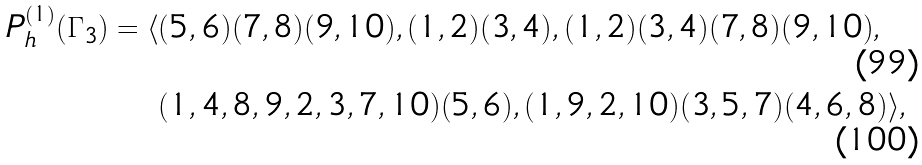<formula> <loc_0><loc_0><loc_500><loc_500>P _ { h } ^ { ( 1 ) } ( \Gamma _ { 3 } ) = \langle & ( 5 , 6 ) ( 7 , 8 ) ( 9 , 1 0 ) , ( 1 , 2 ) ( 3 , 4 ) , ( 1 , 2 ) ( 3 , 4 ) ( 7 , 8 ) ( 9 , 1 0 ) , \\ & ( 1 , 4 , 8 , 9 , 2 , 3 , 7 , 1 0 ) ( 5 , 6 ) , ( 1 , 9 , 2 , 1 0 ) ( 3 , 5 , 7 ) ( 4 , 6 , 8 ) \rangle ,</formula> 